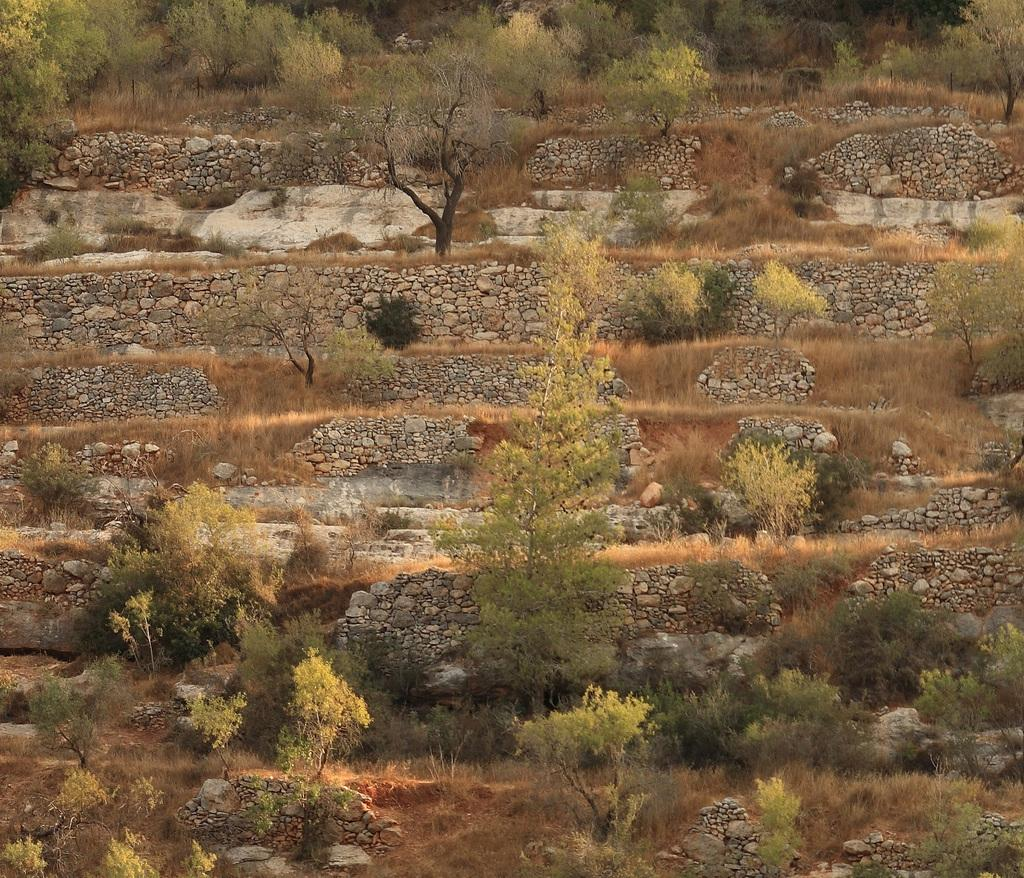What type of natural elements can be seen in the image? There are trees in the image. What other objects can be seen in the image besides trees? There are rocks in the image. What type of paper is your brother holding in the image? There is no brother or paper present in the image; it only features trees and rocks. 